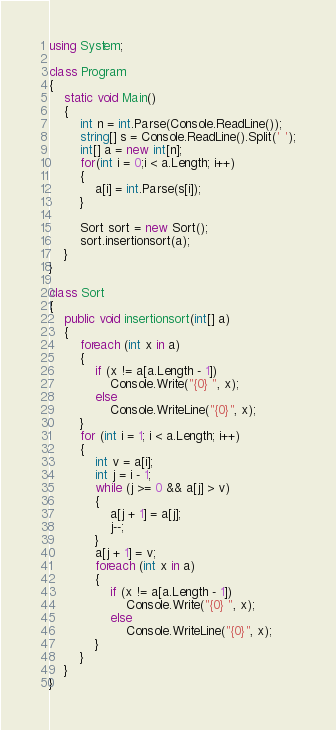<code> <loc_0><loc_0><loc_500><loc_500><_C#_>using System;

class Program
{
    static void Main()
    {
        int n = int.Parse(Console.ReadLine());
        string[] s = Console.ReadLine().Split(' ');
        int[] a = new int[n];
        for(int i = 0;i < a.Length; i++)
        {
            a[i] = int.Parse(s[i]);
        }

        Sort sort = new Sort();
        sort.insertionsort(a);
    }
}

class Sort
{
    public void insertionsort(int[] a)
    {
        foreach (int x in a)
        {
            if (x != a[a.Length - 1])
                Console.Write("{0} ", x);
            else
                Console.WriteLine("{0}", x);
        }
        for (int i = 1; i < a.Length; i++)
        {
            int v = a[i];
            int j = i - 1;
            while (j >= 0 && a[j] > v)
            {
                a[j + 1] = a[j];
                j--;
            }
            a[j + 1] = v;
            foreach (int x in a)
            {
                if (x != a[a.Length - 1])
                    Console.Write("{0} ", x);
                else
                    Console.WriteLine("{0}", x);
            }
        }
    }
}</code> 